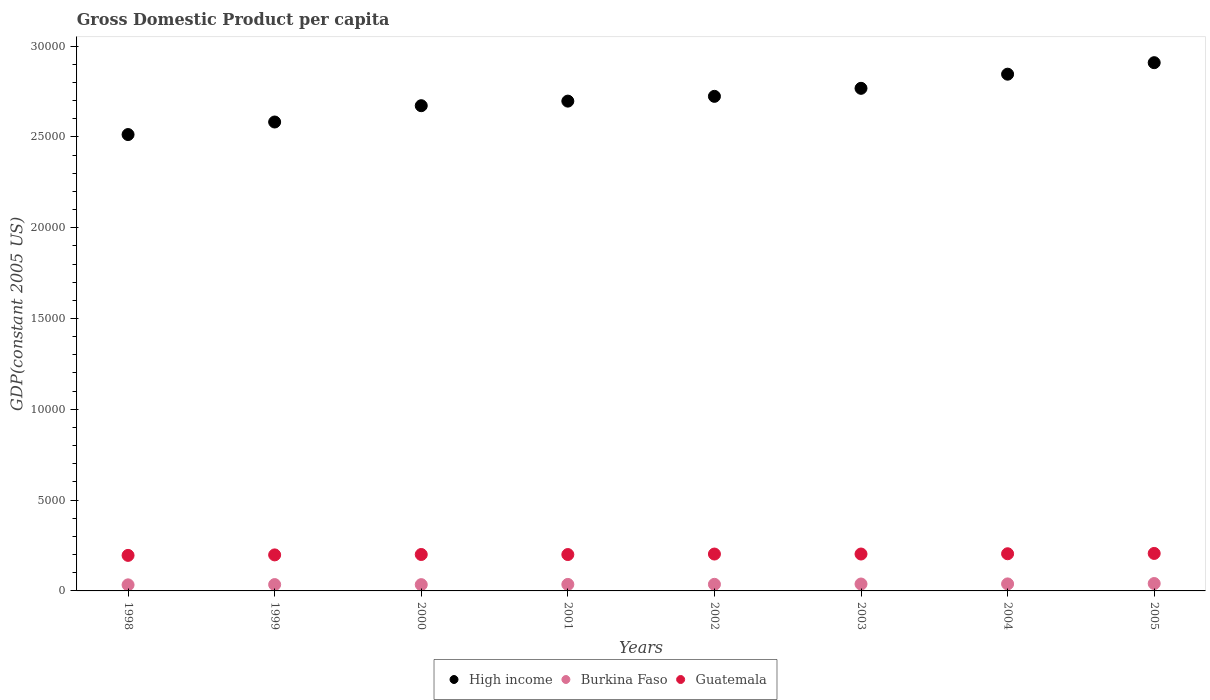Is the number of dotlines equal to the number of legend labels?
Provide a short and direct response. Yes. What is the GDP per capita in Guatemala in 1999?
Provide a succinct answer. 1983.16. Across all years, what is the maximum GDP per capita in High income?
Provide a short and direct response. 2.91e+04. Across all years, what is the minimum GDP per capita in Guatemala?
Your answer should be compact. 1956.34. In which year was the GDP per capita in Burkina Faso minimum?
Your answer should be very brief. 1998. What is the total GDP per capita in High income in the graph?
Ensure brevity in your answer.  2.17e+05. What is the difference between the GDP per capita in Burkina Faso in 2000 and that in 2004?
Ensure brevity in your answer.  -40.26. What is the difference between the GDP per capita in High income in 2002 and the GDP per capita in Burkina Faso in 2000?
Make the answer very short. 2.69e+04. What is the average GDP per capita in High income per year?
Make the answer very short. 2.71e+04. In the year 2001, what is the difference between the GDP per capita in Guatemala and GDP per capita in Burkina Faso?
Provide a succinct answer. 1644.84. What is the ratio of the GDP per capita in High income in 2003 to that in 2004?
Ensure brevity in your answer.  0.97. What is the difference between the highest and the second highest GDP per capita in High income?
Your answer should be very brief. 633.14. What is the difference between the highest and the lowest GDP per capita in High income?
Provide a succinct answer. 3957.01. In how many years, is the GDP per capita in High income greater than the average GDP per capita in High income taken over all years?
Offer a terse response. 4. Is it the case that in every year, the sum of the GDP per capita in Burkina Faso and GDP per capita in Guatemala  is greater than the GDP per capita in High income?
Your answer should be compact. No. Is the GDP per capita in Burkina Faso strictly less than the GDP per capita in High income over the years?
Your answer should be very brief. Yes. How many dotlines are there?
Your response must be concise. 3. What is the difference between two consecutive major ticks on the Y-axis?
Your answer should be compact. 5000. Does the graph contain any zero values?
Provide a succinct answer. No. Does the graph contain grids?
Your answer should be very brief. No. Where does the legend appear in the graph?
Keep it short and to the point. Bottom center. How many legend labels are there?
Offer a terse response. 3. How are the legend labels stacked?
Your answer should be very brief. Horizontal. What is the title of the graph?
Your response must be concise. Gross Domestic Product per capita. Does "Croatia" appear as one of the legend labels in the graph?
Make the answer very short. No. What is the label or title of the X-axis?
Your answer should be compact. Years. What is the label or title of the Y-axis?
Provide a succinct answer. GDP(constant 2005 US). What is the GDP(constant 2005 US) in High income in 1998?
Offer a terse response. 2.51e+04. What is the GDP(constant 2005 US) of Burkina Faso in 1998?
Your answer should be very brief. 334.45. What is the GDP(constant 2005 US) in Guatemala in 1998?
Offer a very short reply. 1956.34. What is the GDP(constant 2005 US) in High income in 1999?
Your answer should be compact. 2.58e+04. What is the GDP(constant 2005 US) of Burkina Faso in 1999?
Your answer should be very brief. 349.22. What is the GDP(constant 2005 US) in Guatemala in 1999?
Offer a very short reply. 1983.16. What is the GDP(constant 2005 US) of High income in 2000?
Offer a terse response. 2.67e+04. What is the GDP(constant 2005 US) of Burkina Faso in 2000?
Give a very brief answer. 345.62. What is the GDP(constant 2005 US) of Guatemala in 2000?
Give a very brief answer. 2005.54. What is the GDP(constant 2005 US) in High income in 2001?
Your response must be concise. 2.70e+04. What is the GDP(constant 2005 US) of Burkina Faso in 2001?
Provide a succinct answer. 358.12. What is the GDP(constant 2005 US) in Guatemala in 2001?
Keep it short and to the point. 2002.96. What is the GDP(constant 2005 US) in High income in 2002?
Give a very brief answer. 2.72e+04. What is the GDP(constant 2005 US) of Burkina Faso in 2002?
Provide a succinct answer. 363.15. What is the GDP(constant 2005 US) in Guatemala in 2002?
Provide a short and direct response. 2030.31. What is the GDP(constant 2005 US) in High income in 2003?
Offer a terse response. 2.77e+04. What is the GDP(constant 2005 US) in Burkina Faso in 2003?
Your answer should be very brief. 380.33. What is the GDP(constant 2005 US) in Guatemala in 2003?
Keep it short and to the point. 2031.84. What is the GDP(constant 2005 US) in High income in 2004?
Your answer should be compact. 2.85e+04. What is the GDP(constant 2005 US) in Burkina Faso in 2004?
Offer a terse response. 385.88. What is the GDP(constant 2005 US) of Guatemala in 2004?
Provide a short and direct response. 2046.35. What is the GDP(constant 2005 US) in High income in 2005?
Keep it short and to the point. 2.91e+04. What is the GDP(constant 2005 US) in Burkina Faso in 2005?
Make the answer very short. 407. What is the GDP(constant 2005 US) in Guatemala in 2005?
Ensure brevity in your answer.  2064.05. Across all years, what is the maximum GDP(constant 2005 US) of High income?
Ensure brevity in your answer.  2.91e+04. Across all years, what is the maximum GDP(constant 2005 US) in Burkina Faso?
Offer a terse response. 407. Across all years, what is the maximum GDP(constant 2005 US) in Guatemala?
Your answer should be very brief. 2064.05. Across all years, what is the minimum GDP(constant 2005 US) of High income?
Make the answer very short. 2.51e+04. Across all years, what is the minimum GDP(constant 2005 US) in Burkina Faso?
Give a very brief answer. 334.45. Across all years, what is the minimum GDP(constant 2005 US) in Guatemala?
Your response must be concise. 1956.34. What is the total GDP(constant 2005 US) in High income in the graph?
Make the answer very short. 2.17e+05. What is the total GDP(constant 2005 US) of Burkina Faso in the graph?
Your answer should be compact. 2923.78. What is the total GDP(constant 2005 US) of Guatemala in the graph?
Make the answer very short. 1.61e+04. What is the difference between the GDP(constant 2005 US) in High income in 1998 and that in 1999?
Give a very brief answer. -690.64. What is the difference between the GDP(constant 2005 US) in Burkina Faso in 1998 and that in 1999?
Your answer should be compact. -14.77. What is the difference between the GDP(constant 2005 US) in Guatemala in 1998 and that in 1999?
Ensure brevity in your answer.  -26.83. What is the difference between the GDP(constant 2005 US) of High income in 1998 and that in 2000?
Your response must be concise. -1588.4. What is the difference between the GDP(constant 2005 US) of Burkina Faso in 1998 and that in 2000?
Offer a terse response. -11.17. What is the difference between the GDP(constant 2005 US) of Guatemala in 1998 and that in 2000?
Offer a very short reply. -49.2. What is the difference between the GDP(constant 2005 US) in High income in 1998 and that in 2001?
Offer a terse response. -1840.67. What is the difference between the GDP(constant 2005 US) of Burkina Faso in 1998 and that in 2001?
Make the answer very short. -23.67. What is the difference between the GDP(constant 2005 US) in Guatemala in 1998 and that in 2001?
Provide a succinct answer. -46.62. What is the difference between the GDP(constant 2005 US) in High income in 1998 and that in 2002?
Offer a very short reply. -2103.65. What is the difference between the GDP(constant 2005 US) in Burkina Faso in 1998 and that in 2002?
Your response must be concise. -28.7. What is the difference between the GDP(constant 2005 US) in Guatemala in 1998 and that in 2002?
Make the answer very short. -73.98. What is the difference between the GDP(constant 2005 US) of High income in 1998 and that in 2003?
Your response must be concise. -2545.33. What is the difference between the GDP(constant 2005 US) in Burkina Faso in 1998 and that in 2003?
Your answer should be very brief. -45.88. What is the difference between the GDP(constant 2005 US) of Guatemala in 1998 and that in 2003?
Offer a terse response. -75.5. What is the difference between the GDP(constant 2005 US) of High income in 1998 and that in 2004?
Provide a short and direct response. -3323.87. What is the difference between the GDP(constant 2005 US) of Burkina Faso in 1998 and that in 2004?
Your answer should be compact. -51.43. What is the difference between the GDP(constant 2005 US) of Guatemala in 1998 and that in 2004?
Your response must be concise. -90.01. What is the difference between the GDP(constant 2005 US) in High income in 1998 and that in 2005?
Give a very brief answer. -3957.01. What is the difference between the GDP(constant 2005 US) of Burkina Faso in 1998 and that in 2005?
Your answer should be very brief. -72.55. What is the difference between the GDP(constant 2005 US) in Guatemala in 1998 and that in 2005?
Your answer should be compact. -107.71. What is the difference between the GDP(constant 2005 US) of High income in 1999 and that in 2000?
Make the answer very short. -897.76. What is the difference between the GDP(constant 2005 US) in Burkina Faso in 1999 and that in 2000?
Provide a short and direct response. 3.6. What is the difference between the GDP(constant 2005 US) in Guatemala in 1999 and that in 2000?
Offer a very short reply. -22.38. What is the difference between the GDP(constant 2005 US) in High income in 1999 and that in 2001?
Provide a succinct answer. -1150.03. What is the difference between the GDP(constant 2005 US) of Burkina Faso in 1999 and that in 2001?
Keep it short and to the point. -8.9. What is the difference between the GDP(constant 2005 US) in Guatemala in 1999 and that in 2001?
Your answer should be compact. -19.79. What is the difference between the GDP(constant 2005 US) in High income in 1999 and that in 2002?
Give a very brief answer. -1413.01. What is the difference between the GDP(constant 2005 US) in Burkina Faso in 1999 and that in 2002?
Give a very brief answer. -13.93. What is the difference between the GDP(constant 2005 US) in Guatemala in 1999 and that in 2002?
Provide a short and direct response. -47.15. What is the difference between the GDP(constant 2005 US) of High income in 1999 and that in 2003?
Make the answer very short. -1854.69. What is the difference between the GDP(constant 2005 US) in Burkina Faso in 1999 and that in 2003?
Offer a terse response. -31.11. What is the difference between the GDP(constant 2005 US) in Guatemala in 1999 and that in 2003?
Provide a succinct answer. -48.68. What is the difference between the GDP(constant 2005 US) in High income in 1999 and that in 2004?
Provide a short and direct response. -2633.23. What is the difference between the GDP(constant 2005 US) of Burkina Faso in 1999 and that in 2004?
Provide a succinct answer. -36.66. What is the difference between the GDP(constant 2005 US) of Guatemala in 1999 and that in 2004?
Your answer should be very brief. -63.18. What is the difference between the GDP(constant 2005 US) in High income in 1999 and that in 2005?
Provide a short and direct response. -3266.37. What is the difference between the GDP(constant 2005 US) in Burkina Faso in 1999 and that in 2005?
Your response must be concise. -57.78. What is the difference between the GDP(constant 2005 US) in Guatemala in 1999 and that in 2005?
Give a very brief answer. -80.89. What is the difference between the GDP(constant 2005 US) of High income in 2000 and that in 2001?
Provide a short and direct response. -252.27. What is the difference between the GDP(constant 2005 US) of Burkina Faso in 2000 and that in 2001?
Provide a short and direct response. -12.5. What is the difference between the GDP(constant 2005 US) of Guatemala in 2000 and that in 2001?
Make the answer very short. 2.58. What is the difference between the GDP(constant 2005 US) of High income in 2000 and that in 2002?
Keep it short and to the point. -515.25. What is the difference between the GDP(constant 2005 US) of Burkina Faso in 2000 and that in 2002?
Keep it short and to the point. -17.53. What is the difference between the GDP(constant 2005 US) of Guatemala in 2000 and that in 2002?
Provide a succinct answer. -24.77. What is the difference between the GDP(constant 2005 US) in High income in 2000 and that in 2003?
Offer a terse response. -956.93. What is the difference between the GDP(constant 2005 US) in Burkina Faso in 2000 and that in 2003?
Your response must be concise. -34.7. What is the difference between the GDP(constant 2005 US) in Guatemala in 2000 and that in 2003?
Ensure brevity in your answer.  -26.3. What is the difference between the GDP(constant 2005 US) of High income in 2000 and that in 2004?
Provide a succinct answer. -1735.47. What is the difference between the GDP(constant 2005 US) of Burkina Faso in 2000 and that in 2004?
Your answer should be compact. -40.26. What is the difference between the GDP(constant 2005 US) in Guatemala in 2000 and that in 2004?
Your answer should be compact. -40.81. What is the difference between the GDP(constant 2005 US) in High income in 2000 and that in 2005?
Offer a terse response. -2368.61. What is the difference between the GDP(constant 2005 US) in Burkina Faso in 2000 and that in 2005?
Offer a very short reply. -61.38. What is the difference between the GDP(constant 2005 US) in Guatemala in 2000 and that in 2005?
Your response must be concise. -58.51. What is the difference between the GDP(constant 2005 US) in High income in 2001 and that in 2002?
Provide a succinct answer. -262.98. What is the difference between the GDP(constant 2005 US) of Burkina Faso in 2001 and that in 2002?
Provide a succinct answer. -5.03. What is the difference between the GDP(constant 2005 US) of Guatemala in 2001 and that in 2002?
Offer a terse response. -27.36. What is the difference between the GDP(constant 2005 US) in High income in 2001 and that in 2003?
Offer a very short reply. -704.66. What is the difference between the GDP(constant 2005 US) of Burkina Faso in 2001 and that in 2003?
Ensure brevity in your answer.  -22.21. What is the difference between the GDP(constant 2005 US) of Guatemala in 2001 and that in 2003?
Provide a succinct answer. -28.88. What is the difference between the GDP(constant 2005 US) of High income in 2001 and that in 2004?
Provide a short and direct response. -1483.2. What is the difference between the GDP(constant 2005 US) in Burkina Faso in 2001 and that in 2004?
Offer a very short reply. -27.76. What is the difference between the GDP(constant 2005 US) in Guatemala in 2001 and that in 2004?
Provide a short and direct response. -43.39. What is the difference between the GDP(constant 2005 US) of High income in 2001 and that in 2005?
Make the answer very short. -2116.34. What is the difference between the GDP(constant 2005 US) of Burkina Faso in 2001 and that in 2005?
Provide a succinct answer. -48.88. What is the difference between the GDP(constant 2005 US) of Guatemala in 2001 and that in 2005?
Keep it short and to the point. -61.09. What is the difference between the GDP(constant 2005 US) of High income in 2002 and that in 2003?
Provide a succinct answer. -441.67. What is the difference between the GDP(constant 2005 US) in Burkina Faso in 2002 and that in 2003?
Ensure brevity in your answer.  -17.18. What is the difference between the GDP(constant 2005 US) in Guatemala in 2002 and that in 2003?
Your answer should be very brief. -1.53. What is the difference between the GDP(constant 2005 US) of High income in 2002 and that in 2004?
Give a very brief answer. -1220.22. What is the difference between the GDP(constant 2005 US) of Burkina Faso in 2002 and that in 2004?
Your response must be concise. -22.73. What is the difference between the GDP(constant 2005 US) of Guatemala in 2002 and that in 2004?
Ensure brevity in your answer.  -16.03. What is the difference between the GDP(constant 2005 US) of High income in 2002 and that in 2005?
Provide a short and direct response. -1853.36. What is the difference between the GDP(constant 2005 US) in Burkina Faso in 2002 and that in 2005?
Offer a terse response. -43.85. What is the difference between the GDP(constant 2005 US) in Guatemala in 2002 and that in 2005?
Offer a very short reply. -33.73. What is the difference between the GDP(constant 2005 US) of High income in 2003 and that in 2004?
Your response must be concise. -778.54. What is the difference between the GDP(constant 2005 US) in Burkina Faso in 2003 and that in 2004?
Offer a very short reply. -5.55. What is the difference between the GDP(constant 2005 US) of Guatemala in 2003 and that in 2004?
Your response must be concise. -14.51. What is the difference between the GDP(constant 2005 US) of High income in 2003 and that in 2005?
Your answer should be very brief. -1411.68. What is the difference between the GDP(constant 2005 US) of Burkina Faso in 2003 and that in 2005?
Your answer should be very brief. -26.67. What is the difference between the GDP(constant 2005 US) of Guatemala in 2003 and that in 2005?
Your answer should be very brief. -32.21. What is the difference between the GDP(constant 2005 US) in High income in 2004 and that in 2005?
Your response must be concise. -633.14. What is the difference between the GDP(constant 2005 US) of Burkina Faso in 2004 and that in 2005?
Ensure brevity in your answer.  -21.12. What is the difference between the GDP(constant 2005 US) in Guatemala in 2004 and that in 2005?
Provide a short and direct response. -17.7. What is the difference between the GDP(constant 2005 US) of High income in 1998 and the GDP(constant 2005 US) of Burkina Faso in 1999?
Give a very brief answer. 2.48e+04. What is the difference between the GDP(constant 2005 US) in High income in 1998 and the GDP(constant 2005 US) in Guatemala in 1999?
Provide a short and direct response. 2.31e+04. What is the difference between the GDP(constant 2005 US) of Burkina Faso in 1998 and the GDP(constant 2005 US) of Guatemala in 1999?
Your answer should be compact. -1648.71. What is the difference between the GDP(constant 2005 US) of High income in 1998 and the GDP(constant 2005 US) of Burkina Faso in 2000?
Ensure brevity in your answer.  2.48e+04. What is the difference between the GDP(constant 2005 US) of High income in 1998 and the GDP(constant 2005 US) of Guatemala in 2000?
Offer a very short reply. 2.31e+04. What is the difference between the GDP(constant 2005 US) of Burkina Faso in 1998 and the GDP(constant 2005 US) of Guatemala in 2000?
Your answer should be compact. -1671.09. What is the difference between the GDP(constant 2005 US) in High income in 1998 and the GDP(constant 2005 US) in Burkina Faso in 2001?
Your answer should be compact. 2.48e+04. What is the difference between the GDP(constant 2005 US) in High income in 1998 and the GDP(constant 2005 US) in Guatemala in 2001?
Your response must be concise. 2.31e+04. What is the difference between the GDP(constant 2005 US) in Burkina Faso in 1998 and the GDP(constant 2005 US) in Guatemala in 2001?
Give a very brief answer. -1668.51. What is the difference between the GDP(constant 2005 US) of High income in 1998 and the GDP(constant 2005 US) of Burkina Faso in 2002?
Offer a very short reply. 2.48e+04. What is the difference between the GDP(constant 2005 US) of High income in 1998 and the GDP(constant 2005 US) of Guatemala in 2002?
Offer a very short reply. 2.31e+04. What is the difference between the GDP(constant 2005 US) in Burkina Faso in 1998 and the GDP(constant 2005 US) in Guatemala in 2002?
Provide a succinct answer. -1695.86. What is the difference between the GDP(constant 2005 US) of High income in 1998 and the GDP(constant 2005 US) of Burkina Faso in 2003?
Ensure brevity in your answer.  2.47e+04. What is the difference between the GDP(constant 2005 US) of High income in 1998 and the GDP(constant 2005 US) of Guatemala in 2003?
Your answer should be very brief. 2.31e+04. What is the difference between the GDP(constant 2005 US) of Burkina Faso in 1998 and the GDP(constant 2005 US) of Guatemala in 2003?
Provide a succinct answer. -1697.39. What is the difference between the GDP(constant 2005 US) of High income in 1998 and the GDP(constant 2005 US) of Burkina Faso in 2004?
Give a very brief answer. 2.47e+04. What is the difference between the GDP(constant 2005 US) in High income in 1998 and the GDP(constant 2005 US) in Guatemala in 2004?
Offer a terse response. 2.31e+04. What is the difference between the GDP(constant 2005 US) of Burkina Faso in 1998 and the GDP(constant 2005 US) of Guatemala in 2004?
Provide a short and direct response. -1711.9. What is the difference between the GDP(constant 2005 US) of High income in 1998 and the GDP(constant 2005 US) of Burkina Faso in 2005?
Give a very brief answer. 2.47e+04. What is the difference between the GDP(constant 2005 US) in High income in 1998 and the GDP(constant 2005 US) in Guatemala in 2005?
Offer a very short reply. 2.31e+04. What is the difference between the GDP(constant 2005 US) of Burkina Faso in 1998 and the GDP(constant 2005 US) of Guatemala in 2005?
Your answer should be compact. -1729.6. What is the difference between the GDP(constant 2005 US) of High income in 1999 and the GDP(constant 2005 US) of Burkina Faso in 2000?
Keep it short and to the point. 2.55e+04. What is the difference between the GDP(constant 2005 US) in High income in 1999 and the GDP(constant 2005 US) in Guatemala in 2000?
Your answer should be compact. 2.38e+04. What is the difference between the GDP(constant 2005 US) of Burkina Faso in 1999 and the GDP(constant 2005 US) of Guatemala in 2000?
Your response must be concise. -1656.32. What is the difference between the GDP(constant 2005 US) in High income in 1999 and the GDP(constant 2005 US) in Burkina Faso in 2001?
Offer a terse response. 2.55e+04. What is the difference between the GDP(constant 2005 US) of High income in 1999 and the GDP(constant 2005 US) of Guatemala in 2001?
Make the answer very short. 2.38e+04. What is the difference between the GDP(constant 2005 US) of Burkina Faso in 1999 and the GDP(constant 2005 US) of Guatemala in 2001?
Keep it short and to the point. -1653.74. What is the difference between the GDP(constant 2005 US) in High income in 1999 and the GDP(constant 2005 US) in Burkina Faso in 2002?
Provide a succinct answer. 2.55e+04. What is the difference between the GDP(constant 2005 US) of High income in 1999 and the GDP(constant 2005 US) of Guatemala in 2002?
Offer a terse response. 2.38e+04. What is the difference between the GDP(constant 2005 US) in Burkina Faso in 1999 and the GDP(constant 2005 US) in Guatemala in 2002?
Your answer should be compact. -1681.09. What is the difference between the GDP(constant 2005 US) in High income in 1999 and the GDP(constant 2005 US) in Burkina Faso in 2003?
Keep it short and to the point. 2.54e+04. What is the difference between the GDP(constant 2005 US) of High income in 1999 and the GDP(constant 2005 US) of Guatemala in 2003?
Offer a terse response. 2.38e+04. What is the difference between the GDP(constant 2005 US) in Burkina Faso in 1999 and the GDP(constant 2005 US) in Guatemala in 2003?
Ensure brevity in your answer.  -1682.62. What is the difference between the GDP(constant 2005 US) of High income in 1999 and the GDP(constant 2005 US) of Burkina Faso in 2004?
Keep it short and to the point. 2.54e+04. What is the difference between the GDP(constant 2005 US) in High income in 1999 and the GDP(constant 2005 US) in Guatemala in 2004?
Offer a terse response. 2.38e+04. What is the difference between the GDP(constant 2005 US) of Burkina Faso in 1999 and the GDP(constant 2005 US) of Guatemala in 2004?
Make the answer very short. -1697.13. What is the difference between the GDP(constant 2005 US) of High income in 1999 and the GDP(constant 2005 US) of Burkina Faso in 2005?
Your answer should be very brief. 2.54e+04. What is the difference between the GDP(constant 2005 US) of High income in 1999 and the GDP(constant 2005 US) of Guatemala in 2005?
Provide a succinct answer. 2.38e+04. What is the difference between the GDP(constant 2005 US) in Burkina Faso in 1999 and the GDP(constant 2005 US) in Guatemala in 2005?
Ensure brevity in your answer.  -1714.83. What is the difference between the GDP(constant 2005 US) of High income in 2000 and the GDP(constant 2005 US) of Burkina Faso in 2001?
Offer a terse response. 2.64e+04. What is the difference between the GDP(constant 2005 US) in High income in 2000 and the GDP(constant 2005 US) in Guatemala in 2001?
Provide a succinct answer. 2.47e+04. What is the difference between the GDP(constant 2005 US) in Burkina Faso in 2000 and the GDP(constant 2005 US) in Guatemala in 2001?
Give a very brief answer. -1657.33. What is the difference between the GDP(constant 2005 US) of High income in 2000 and the GDP(constant 2005 US) of Burkina Faso in 2002?
Ensure brevity in your answer.  2.64e+04. What is the difference between the GDP(constant 2005 US) of High income in 2000 and the GDP(constant 2005 US) of Guatemala in 2002?
Offer a terse response. 2.47e+04. What is the difference between the GDP(constant 2005 US) of Burkina Faso in 2000 and the GDP(constant 2005 US) of Guatemala in 2002?
Your answer should be compact. -1684.69. What is the difference between the GDP(constant 2005 US) in High income in 2000 and the GDP(constant 2005 US) in Burkina Faso in 2003?
Ensure brevity in your answer.  2.63e+04. What is the difference between the GDP(constant 2005 US) of High income in 2000 and the GDP(constant 2005 US) of Guatemala in 2003?
Give a very brief answer. 2.47e+04. What is the difference between the GDP(constant 2005 US) of Burkina Faso in 2000 and the GDP(constant 2005 US) of Guatemala in 2003?
Offer a very short reply. -1686.21. What is the difference between the GDP(constant 2005 US) of High income in 2000 and the GDP(constant 2005 US) of Burkina Faso in 2004?
Provide a succinct answer. 2.63e+04. What is the difference between the GDP(constant 2005 US) of High income in 2000 and the GDP(constant 2005 US) of Guatemala in 2004?
Your answer should be compact. 2.47e+04. What is the difference between the GDP(constant 2005 US) of Burkina Faso in 2000 and the GDP(constant 2005 US) of Guatemala in 2004?
Give a very brief answer. -1700.72. What is the difference between the GDP(constant 2005 US) of High income in 2000 and the GDP(constant 2005 US) of Burkina Faso in 2005?
Give a very brief answer. 2.63e+04. What is the difference between the GDP(constant 2005 US) in High income in 2000 and the GDP(constant 2005 US) in Guatemala in 2005?
Provide a succinct answer. 2.47e+04. What is the difference between the GDP(constant 2005 US) of Burkina Faso in 2000 and the GDP(constant 2005 US) of Guatemala in 2005?
Give a very brief answer. -1718.42. What is the difference between the GDP(constant 2005 US) of High income in 2001 and the GDP(constant 2005 US) of Burkina Faso in 2002?
Offer a very short reply. 2.66e+04. What is the difference between the GDP(constant 2005 US) of High income in 2001 and the GDP(constant 2005 US) of Guatemala in 2002?
Ensure brevity in your answer.  2.49e+04. What is the difference between the GDP(constant 2005 US) of Burkina Faso in 2001 and the GDP(constant 2005 US) of Guatemala in 2002?
Your response must be concise. -1672.19. What is the difference between the GDP(constant 2005 US) of High income in 2001 and the GDP(constant 2005 US) of Burkina Faso in 2003?
Provide a short and direct response. 2.66e+04. What is the difference between the GDP(constant 2005 US) of High income in 2001 and the GDP(constant 2005 US) of Guatemala in 2003?
Your response must be concise. 2.49e+04. What is the difference between the GDP(constant 2005 US) of Burkina Faso in 2001 and the GDP(constant 2005 US) of Guatemala in 2003?
Provide a short and direct response. -1673.72. What is the difference between the GDP(constant 2005 US) in High income in 2001 and the GDP(constant 2005 US) in Burkina Faso in 2004?
Offer a terse response. 2.66e+04. What is the difference between the GDP(constant 2005 US) of High income in 2001 and the GDP(constant 2005 US) of Guatemala in 2004?
Offer a very short reply. 2.49e+04. What is the difference between the GDP(constant 2005 US) of Burkina Faso in 2001 and the GDP(constant 2005 US) of Guatemala in 2004?
Keep it short and to the point. -1688.23. What is the difference between the GDP(constant 2005 US) of High income in 2001 and the GDP(constant 2005 US) of Burkina Faso in 2005?
Your response must be concise. 2.66e+04. What is the difference between the GDP(constant 2005 US) in High income in 2001 and the GDP(constant 2005 US) in Guatemala in 2005?
Your answer should be compact. 2.49e+04. What is the difference between the GDP(constant 2005 US) in Burkina Faso in 2001 and the GDP(constant 2005 US) in Guatemala in 2005?
Make the answer very short. -1705.93. What is the difference between the GDP(constant 2005 US) of High income in 2002 and the GDP(constant 2005 US) of Burkina Faso in 2003?
Ensure brevity in your answer.  2.69e+04. What is the difference between the GDP(constant 2005 US) of High income in 2002 and the GDP(constant 2005 US) of Guatemala in 2003?
Provide a succinct answer. 2.52e+04. What is the difference between the GDP(constant 2005 US) of Burkina Faso in 2002 and the GDP(constant 2005 US) of Guatemala in 2003?
Provide a succinct answer. -1668.69. What is the difference between the GDP(constant 2005 US) in High income in 2002 and the GDP(constant 2005 US) in Burkina Faso in 2004?
Your answer should be compact. 2.68e+04. What is the difference between the GDP(constant 2005 US) in High income in 2002 and the GDP(constant 2005 US) in Guatemala in 2004?
Make the answer very short. 2.52e+04. What is the difference between the GDP(constant 2005 US) of Burkina Faso in 2002 and the GDP(constant 2005 US) of Guatemala in 2004?
Make the answer very short. -1683.19. What is the difference between the GDP(constant 2005 US) of High income in 2002 and the GDP(constant 2005 US) of Burkina Faso in 2005?
Give a very brief answer. 2.68e+04. What is the difference between the GDP(constant 2005 US) in High income in 2002 and the GDP(constant 2005 US) in Guatemala in 2005?
Offer a terse response. 2.52e+04. What is the difference between the GDP(constant 2005 US) of Burkina Faso in 2002 and the GDP(constant 2005 US) of Guatemala in 2005?
Offer a terse response. -1700.89. What is the difference between the GDP(constant 2005 US) in High income in 2003 and the GDP(constant 2005 US) in Burkina Faso in 2004?
Provide a succinct answer. 2.73e+04. What is the difference between the GDP(constant 2005 US) in High income in 2003 and the GDP(constant 2005 US) in Guatemala in 2004?
Give a very brief answer. 2.56e+04. What is the difference between the GDP(constant 2005 US) in Burkina Faso in 2003 and the GDP(constant 2005 US) in Guatemala in 2004?
Make the answer very short. -1666.02. What is the difference between the GDP(constant 2005 US) in High income in 2003 and the GDP(constant 2005 US) in Burkina Faso in 2005?
Provide a succinct answer. 2.73e+04. What is the difference between the GDP(constant 2005 US) of High income in 2003 and the GDP(constant 2005 US) of Guatemala in 2005?
Your answer should be compact. 2.56e+04. What is the difference between the GDP(constant 2005 US) in Burkina Faso in 2003 and the GDP(constant 2005 US) in Guatemala in 2005?
Provide a short and direct response. -1683.72. What is the difference between the GDP(constant 2005 US) of High income in 2004 and the GDP(constant 2005 US) of Burkina Faso in 2005?
Your response must be concise. 2.80e+04. What is the difference between the GDP(constant 2005 US) in High income in 2004 and the GDP(constant 2005 US) in Guatemala in 2005?
Your response must be concise. 2.64e+04. What is the difference between the GDP(constant 2005 US) in Burkina Faso in 2004 and the GDP(constant 2005 US) in Guatemala in 2005?
Offer a terse response. -1678.17. What is the average GDP(constant 2005 US) of High income per year?
Give a very brief answer. 2.71e+04. What is the average GDP(constant 2005 US) in Burkina Faso per year?
Provide a succinct answer. 365.47. What is the average GDP(constant 2005 US) of Guatemala per year?
Make the answer very short. 2015.07. In the year 1998, what is the difference between the GDP(constant 2005 US) in High income and GDP(constant 2005 US) in Burkina Faso?
Provide a succinct answer. 2.48e+04. In the year 1998, what is the difference between the GDP(constant 2005 US) in High income and GDP(constant 2005 US) in Guatemala?
Provide a succinct answer. 2.32e+04. In the year 1998, what is the difference between the GDP(constant 2005 US) of Burkina Faso and GDP(constant 2005 US) of Guatemala?
Make the answer very short. -1621.89. In the year 1999, what is the difference between the GDP(constant 2005 US) of High income and GDP(constant 2005 US) of Burkina Faso?
Offer a very short reply. 2.55e+04. In the year 1999, what is the difference between the GDP(constant 2005 US) of High income and GDP(constant 2005 US) of Guatemala?
Keep it short and to the point. 2.38e+04. In the year 1999, what is the difference between the GDP(constant 2005 US) in Burkina Faso and GDP(constant 2005 US) in Guatemala?
Ensure brevity in your answer.  -1633.94. In the year 2000, what is the difference between the GDP(constant 2005 US) of High income and GDP(constant 2005 US) of Burkina Faso?
Ensure brevity in your answer.  2.64e+04. In the year 2000, what is the difference between the GDP(constant 2005 US) of High income and GDP(constant 2005 US) of Guatemala?
Give a very brief answer. 2.47e+04. In the year 2000, what is the difference between the GDP(constant 2005 US) of Burkina Faso and GDP(constant 2005 US) of Guatemala?
Ensure brevity in your answer.  -1659.91. In the year 2001, what is the difference between the GDP(constant 2005 US) in High income and GDP(constant 2005 US) in Burkina Faso?
Your response must be concise. 2.66e+04. In the year 2001, what is the difference between the GDP(constant 2005 US) of High income and GDP(constant 2005 US) of Guatemala?
Make the answer very short. 2.50e+04. In the year 2001, what is the difference between the GDP(constant 2005 US) in Burkina Faso and GDP(constant 2005 US) in Guatemala?
Offer a terse response. -1644.84. In the year 2002, what is the difference between the GDP(constant 2005 US) of High income and GDP(constant 2005 US) of Burkina Faso?
Your response must be concise. 2.69e+04. In the year 2002, what is the difference between the GDP(constant 2005 US) in High income and GDP(constant 2005 US) in Guatemala?
Offer a terse response. 2.52e+04. In the year 2002, what is the difference between the GDP(constant 2005 US) of Burkina Faso and GDP(constant 2005 US) of Guatemala?
Offer a terse response. -1667.16. In the year 2003, what is the difference between the GDP(constant 2005 US) in High income and GDP(constant 2005 US) in Burkina Faso?
Offer a very short reply. 2.73e+04. In the year 2003, what is the difference between the GDP(constant 2005 US) of High income and GDP(constant 2005 US) of Guatemala?
Provide a succinct answer. 2.56e+04. In the year 2003, what is the difference between the GDP(constant 2005 US) of Burkina Faso and GDP(constant 2005 US) of Guatemala?
Offer a terse response. -1651.51. In the year 2004, what is the difference between the GDP(constant 2005 US) in High income and GDP(constant 2005 US) in Burkina Faso?
Provide a short and direct response. 2.81e+04. In the year 2004, what is the difference between the GDP(constant 2005 US) of High income and GDP(constant 2005 US) of Guatemala?
Your answer should be compact. 2.64e+04. In the year 2004, what is the difference between the GDP(constant 2005 US) in Burkina Faso and GDP(constant 2005 US) in Guatemala?
Your answer should be very brief. -1660.47. In the year 2005, what is the difference between the GDP(constant 2005 US) of High income and GDP(constant 2005 US) of Burkina Faso?
Your response must be concise. 2.87e+04. In the year 2005, what is the difference between the GDP(constant 2005 US) of High income and GDP(constant 2005 US) of Guatemala?
Your answer should be very brief. 2.70e+04. In the year 2005, what is the difference between the GDP(constant 2005 US) in Burkina Faso and GDP(constant 2005 US) in Guatemala?
Offer a very short reply. -1657.05. What is the ratio of the GDP(constant 2005 US) in High income in 1998 to that in 1999?
Offer a terse response. 0.97. What is the ratio of the GDP(constant 2005 US) of Burkina Faso in 1998 to that in 1999?
Ensure brevity in your answer.  0.96. What is the ratio of the GDP(constant 2005 US) of Guatemala in 1998 to that in 1999?
Provide a short and direct response. 0.99. What is the ratio of the GDP(constant 2005 US) of High income in 1998 to that in 2000?
Your response must be concise. 0.94. What is the ratio of the GDP(constant 2005 US) of Guatemala in 1998 to that in 2000?
Provide a short and direct response. 0.98. What is the ratio of the GDP(constant 2005 US) of High income in 1998 to that in 2001?
Offer a very short reply. 0.93. What is the ratio of the GDP(constant 2005 US) in Burkina Faso in 1998 to that in 2001?
Ensure brevity in your answer.  0.93. What is the ratio of the GDP(constant 2005 US) in Guatemala in 1998 to that in 2001?
Your answer should be compact. 0.98. What is the ratio of the GDP(constant 2005 US) in High income in 1998 to that in 2002?
Provide a succinct answer. 0.92. What is the ratio of the GDP(constant 2005 US) in Burkina Faso in 1998 to that in 2002?
Keep it short and to the point. 0.92. What is the ratio of the GDP(constant 2005 US) in Guatemala in 1998 to that in 2002?
Make the answer very short. 0.96. What is the ratio of the GDP(constant 2005 US) in High income in 1998 to that in 2003?
Ensure brevity in your answer.  0.91. What is the ratio of the GDP(constant 2005 US) of Burkina Faso in 1998 to that in 2003?
Your answer should be compact. 0.88. What is the ratio of the GDP(constant 2005 US) in Guatemala in 1998 to that in 2003?
Give a very brief answer. 0.96. What is the ratio of the GDP(constant 2005 US) in High income in 1998 to that in 2004?
Make the answer very short. 0.88. What is the ratio of the GDP(constant 2005 US) of Burkina Faso in 1998 to that in 2004?
Your answer should be very brief. 0.87. What is the ratio of the GDP(constant 2005 US) of Guatemala in 1998 to that in 2004?
Ensure brevity in your answer.  0.96. What is the ratio of the GDP(constant 2005 US) of High income in 1998 to that in 2005?
Offer a terse response. 0.86. What is the ratio of the GDP(constant 2005 US) of Burkina Faso in 1998 to that in 2005?
Offer a terse response. 0.82. What is the ratio of the GDP(constant 2005 US) in Guatemala in 1998 to that in 2005?
Provide a succinct answer. 0.95. What is the ratio of the GDP(constant 2005 US) of High income in 1999 to that in 2000?
Your answer should be very brief. 0.97. What is the ratio of the GDP(constant 2005 US) in Burkina Faso in 1999 to that in 2000?
Make the answer very short. 1.01. What is the ratio of the GDP(constant 2005 US) in High income in 1999 to that in 2001?
Your answer should be compact. 0.96. What is the ratio of the GDP(constant 2005 US) in Burkina Faso in 1999 to that in 2001?
Make the answer very short. 0.98. What is the ratio of the GDP(constant 2005 US) in Guatemala in 1999 to that in 2001?
Provide a short and direct response. 0.99. What is the ratio of the GDP(constant 2005 US) in High income in 1999 to that in 2002?
Provide a short and direct response. 0.95. What is the ratio of the GDP(constant 2005 US) of Burkina Faso in 1999 to that in 2002?
Keep it short and to the point. 0.96. What is the ratio of the GDP(constant 2005 US) in Guatemala in 1999 to that in 2002?
Provide a succinct answer. 0.98. What is the ratio of the GDP(constant 2005 US) of High income in 1999 to that in 2003?
Ensure brevity in your answer.  0.93. What is the ratio of the GDP(constant 2005 US) in Burkina Faso in 1999 to that in 2003?
Keep it short and to the point. 0.92. What is the ratio of the GDP(constant 2005 US) of Guatemala in 1999 to that in 2003?
Your answer should be very brief. 0.98. What is the ratio of the GDP(constant 2005 US) of High income in 1999 to that in 2004?
Your answer should be compact. 0.91. What is the ratio of the GDP(constant 2005 US) of Burkina Faso in 1999 to that in 2004?
Give a very brief answer. 0.91. What is the ratio of the GDP(constant 2005 US) of Guatemala in 1999 to that in 2004?
Give a very brief answer. 0.97. What is the ratio of the GDP(constant 2005 US) of High income in 1999 to that in 2005?
Give a very brief answer. 0.89. What is the ratio of the GDP(constant 2005 US) of Burkina Faso in 1999 to that in 2005?
Provide a short and direct response. 0.86. What is the ratio of the GDP(constant 2005 US) in Guatemala in 1999 to that in 2005?
Keep it short and to the point. 0.96. What is the ratio of the GDP(constant 2005 US) of High income in 2000 to that in 2001?
Offer a very short reply. 0.99. What is the ratio of the GDP(constant 2005 US) of Burkina Faso in 2000 to that in 2001?
Provide a short and direct response. 0.97. What is the ratio of the GDP(constant 2005 US) of High income in 2000 to that in 2002?
Your response must be concise. 0.98. What is the ratio of the GDP(constant 2005 US) of Burkina Faso in 2000 to that in 2002?
Ensure brevity in your answer.  0.95. What is the ratio of the GDP(constant 2005 US) in High income in 2000 to that in 2003?
Your response must be concise. 0.97. What is the ratio of the GDP(constant 2005 US) of Burkina Faso in 2000 to that in 2003?
Make the answer very short. 0.91. What is the ratio of the GDP(constant 2005 US) of Guatemala in 2000 to that in 2003?
Provide a succinct answer. 0.99. What is the ratio of the GDP(constant 2005 US) in High income in 2000 to that in 2004?
Your answer should be very brief. 0.94. What is the ratio of the GDP(constant 2005 US) in Burkina Faso in 2000 to that in 2004?
Provide a short and direct response. 0.9. What is the ratio of the GDP(constant 2005 US) in Guatemala in 2000 to that in 2004?
Offer a very short reply. 0.98. What is the ratio of the GDP(constant 2005 US) of High income in 2000 to that in 2005?
Provide a succinct answer. 0.92. What is the ratio of the GDP(constant 2005 US) in Burkina Faso in 2000 to that in 2005?
Offer a terse response. 0.85. What is the ratio of the GDP(constant 2005 US) in Guatemala in 2000 to that in 2005?
Offer a very short reply. 0.97. What is the ratio of the GDP(constant 2005 US) of High income in 2001 to that in 2002?
Your response must be concise. 0.99. What is the ratio of the GDP(constant 2005 US) in Burkina Faso in 2001 to that in 2002?
Make the answer very short. 0.99. What is the ratio of the GDP(constant 2005 US) in Guatemala in 2001 to that in 2002?
Your answer should be very brief. 0.99. What is the ratio of the GDP(constant 2005 US) in High income in 2001 to that in 2003?
Give a very brief answer. 0.97. What is the ratio of the GDP(constant 2005 US) of Burkina Faso in 2001 to that in 2003?
Your answer should be very brief. 0.94. What is the ratio of the GDP(constant 2005 US) in Guatemala in 2001 to that in 2003?
Give a very brief answer. 0.99. What is the ratio of the GDP(constant 2005 US) in High income in 2001 to that in 2004?
Give a very brief answer. 0.95. What is the ratio of the GDP(constant 2005 US) of Burkina Faso in 2001 to that in 2004?
Your response must be concise. 0.93. What is the ratio of the GDP(constant 2005 US) in Guatemala in 2001 to that in 2004?
Provide a short and direct response. 0.98. What is the ratio of the GDP(constant 2005 US) of High income in 2001 to that in 2005?
Ensure brevity in your answer.  0.93. What is the ratio of the GDP(constant 2005 US) in Burkina Faso in 2001 to that in 2005?
Offer a very short reply. 0.88. What is the ratio of the GDP(constant 2005 US) of Guatemala in 2001 to that in 2005?
Offer a terse response. 0.97. What is the ratio of the GDP(constant 2005 US) of Burkina Faso in 2002 to that in 2003?
Give a very brief answer. 0.95. What is the ratio of the GDP(constant 2005 US) in Guatemala in 2002 to that in 2003?
Give a very brief answer. 1. What is the ratio of the GDP(constant 2005 US) of High income in 2002 to that in 2004?
Make the answer very short. 0.96. What is the ratio of the GDP(constant 2005 US) in Burkina Faso in 2002 to that in 2004?
Keep it short and to the point. 0.94. What is the ratio of the GDP(constant 2005 US) in Guatemala in 2002 to that in 2004?
Provide a succinct answer. 0.99. What is the ratio of the GDP(constant 2005 US) in High income in 2002 to that in 2005?
Your answer should be very brief. 0.94. What is the ratio of the GDP(constant 2005 US) of Burkina Faso in 2002 to that in 2005?
Give a very brief answer. 0.89. What is the ratio of the GDP(constant 2005 US) of Guatemala in 2002 to that in 2005?
Provide a short and direct response. 0.98. What is the ratio of the GDP(constant 2005 US) of High income in 2003 to that in 2004?
Your response must be concise. 0.97. What is the ratio of the GDP(constant 2005 US) in Burkina Faso in 2003 to that in 2004?
Your answer should be compact. 0.99. What is the ratio of the GDP(constant 2005 US) in High income in 2003 to that in 2005?
Your answer should be compact. 0.95. What is the ratio of the GDP(constant 2005 US) in Burkina Faso in 2003 to that in 2005?
Offer a very short reply. 0.93. What is the ratio of the GDP(constant 2005 US) of Guatemala in 2003 to that in 2005?
Offer a very short reply. 0.98. What is the ratio of the GDP(constant 2005 US) in High income in 2004 to that in 2005?
Provide a short and direct response. 0.98. What is the ratio of the GDP(constant 2005 US) of Burkina Faso in 2004 to that in 2005?
Provide a succinct answer. 0.95. What is the ratio of the GDP(constant 2005 US) in Guatemala in 2004 to that in 2005?
Your answer should be very brief. 0.99. What is the difference between the highest and the second highest GDP(constant 2005 US) in High income?
Give a very brief answer. 633.14. What is the difference between the highest and the second highest GDP(constant 2005 US) in Burkina Faso?
Give a very brief answer. 21.12. What is the difference between the highest and the second highest GDP(constant 2005 US) of Guatemala?
Offer a terse response. 17.7. What is the difference between the highest and the lowest GDP(constant 2005 US) of High income?
Your answer should be very brief. 3957.01. What is the difference between the highest and the lowest GDP(constant 2005 US) in Burkina Faso?
Make the answer very short. 72.55. What is the difference between the highest and the lowest GDP(constant 2005 US) of Guatemala?
Make the answer very short. 107.71. 